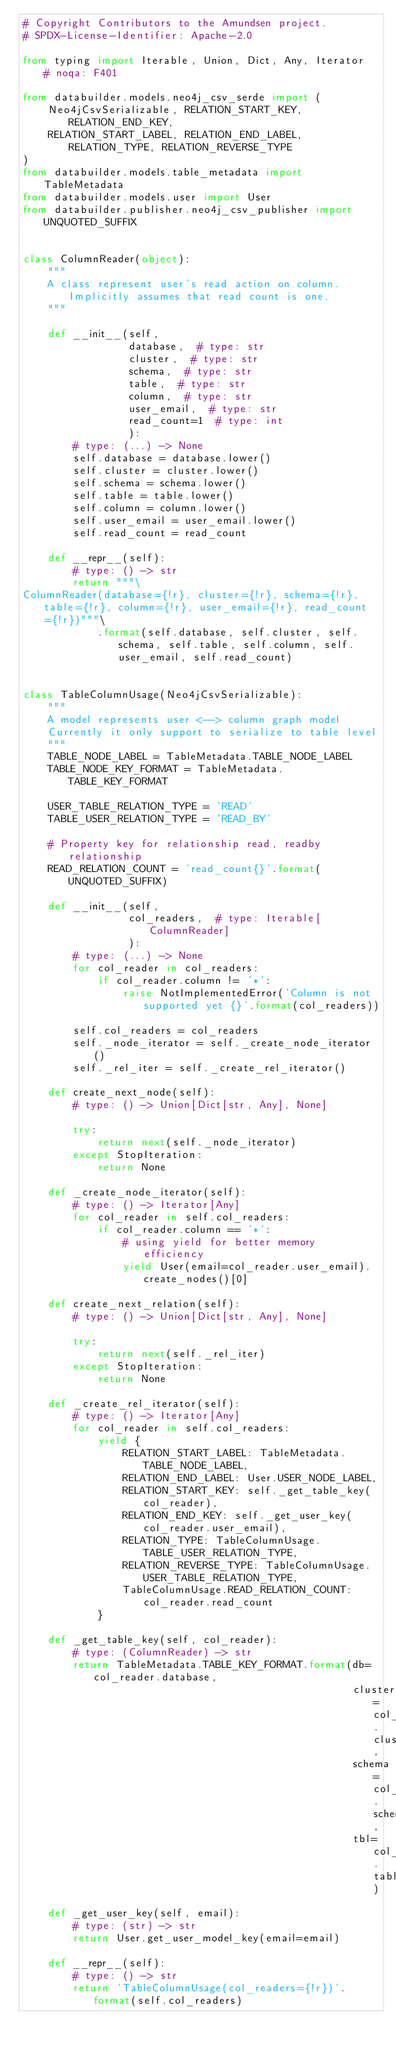<code> <loc_0><loc_0><loc_500><loc_500><_Python_># Copyright Contributors to the Amundsen project.
# SPDX-License-Identifier: Apache-2.0

from typing import Iterable, Union, Dict, Any, Iterator  # noqa: F401

from databuilder.models.neo4j_csv_serde import (
    Neo4jCsvSerializable, RELATION_START_KEY, RELATION_END_KEY,
    RELATION_START_LABEL, RELATION_END_LABEL, RELATION_TYPE, RELATION_REVERSE_TYPE
)
from databuilder.models.table_metadata import TableMetadata
from databuilder.models.user import User
from databuilder.publisher.neo4j_csv_publisher import UNQUOTED_SUFFIX


class ColumnReader(object):
    """
    A class represent user's read action on column. Implicitly assumes that read count is one.
    """

    def __init__(self,
                 database,  # type: str
                 cluster,  # type: str
                 schema,  # type: str
                 table,  # type: str
                 column,  # type: str
                 user_email,  # type: str
                 read_count=1  # type: int
                 ):
        # type: (...) -> None
        self.database = database.lower()
        self.cluster = cluster.lower()
        self.schema = schema.lower()
        self.table = table.lower()
        self.column = column.lower()
        self.user_email = user_email.lower()
        self.read_count = read_count

    def __repr__(self):
        # type: () -> str
        return """\
ColumnReader(database={!r}, cluster={!r}, schema={!r}, table={!r}, column={!r}, user_email={!r}, read_count={!r})"""\
            .format(self.database, self.cluster, self.schema, self.table, self.column, self.user_email, self.read_count)


class TableColumnUsage(Neo4jCsvSerializable):
    """
    A model represents user <--> column graph model
    Currently it only support to serialize to table level
    """
    TABLE_NODE_LABEL = TableMetadata.TABLE_NODE_LABEL
    TABLE_NODE_KEY_FORMAT = TableMetadata.TABLE_KEY_FORMAT

    USER_TABLE_RELATION_TYPE = 'READ'
    TABLE_USER_RELATION_TYPE = 'READ_BY'

    # Property key for relationship read, readby relationship
    READ_RELATION_COUNT = 'read_count{}'.format(UNQUOTED_SUFFIX)

    def __init__(self,
                 col_readers,  # type: Iterable[ColumnReader]
                 ):
        # type: (...) -> None
        for col_reader in col_readers:
            if col_reader.column != '*':
                raise NotImplementedError('Column is not supported yet {}'.format(col_readers))

        self.col_readers = col_readers
        self._node_iterator = self._create_node_iterator()
        self._rel_iter = self._create_rel_iterator()

    def create_next_node(self):
        # type: () -> Union[Dict[str, Any], None]

        try:
            return next(self._node_iterator)
        except StopIteration:
            return None

    def _create_node_iterator(self):
        # type: () -> Iterator[Any]
        for col_reader in self.col_readers:
            if col_reader.column == '*':
                # using yield for better memory efficiency
                yield User(email=col_reader.user_email).create_nodes()[0]

    def create_next_relation(self):
        # type: () -> Union[Dict[str, Any], None]

        try:
            return next(self._rel_iter)
        except StopIteration:
            return None

    def _create_rel_iterator(self):
        # type: () -> Iterator[Any]
        for col_reader in self.col_readers:
            yield {
                RELATION_START_LABEL: TableMetadata.TABLE_NODE_LABEL,
                RELATION_END_LABEL: User.USER_NODE_LABEL,
                RELATION_START_KEY: self._get_table_key(col_reader),
                RELATION_END_KEY: self._get_user_key(col_reader.user_email),
                RELATION_TYPE: TableColumnUsage.TABLE_USER_RELATION_TYPE,
                RELATION_REVERSE_TYPE: TableColumnUsage.USER_TABLE_RELATION_TYPE,
                TableColumnUsage.READ_RELATION_COUNT: col_reader.read_count
            }

    def _get_table_key(self, col_reader):
        # type: (ColumnReader) -> str
        return TableMetadata.TABLE_KEY_FORMAT.format(db=col_reader.database,
                                                     cluster=col_reader.cluster,
                                                     schema=col_reader.schema,
                                                     tbl=col_reader.table)

    def _get_user_key(self, email):
        # type: (str) -> str
        return User.get_user_model_key(email=email)

    def __repr__(self):
        # type: () -> str
        return 'TableColumnUsage(col_readers={!r})'.format(self.col_readers)
</code> 